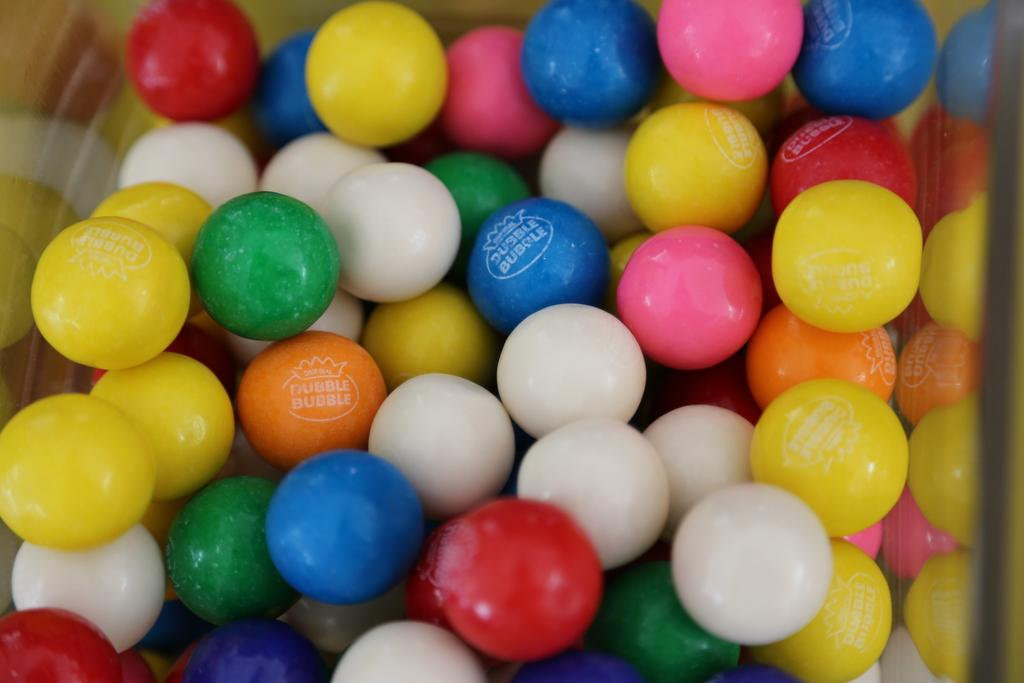What type of objects can be seen in the image? There are colorful candies in the image. How are the candies contained or displayed? The candies are in a glass object. How many sticks are used to propel the goose in the image? There is no goose or stick present in the image; it features colorful candies in a glass object. 